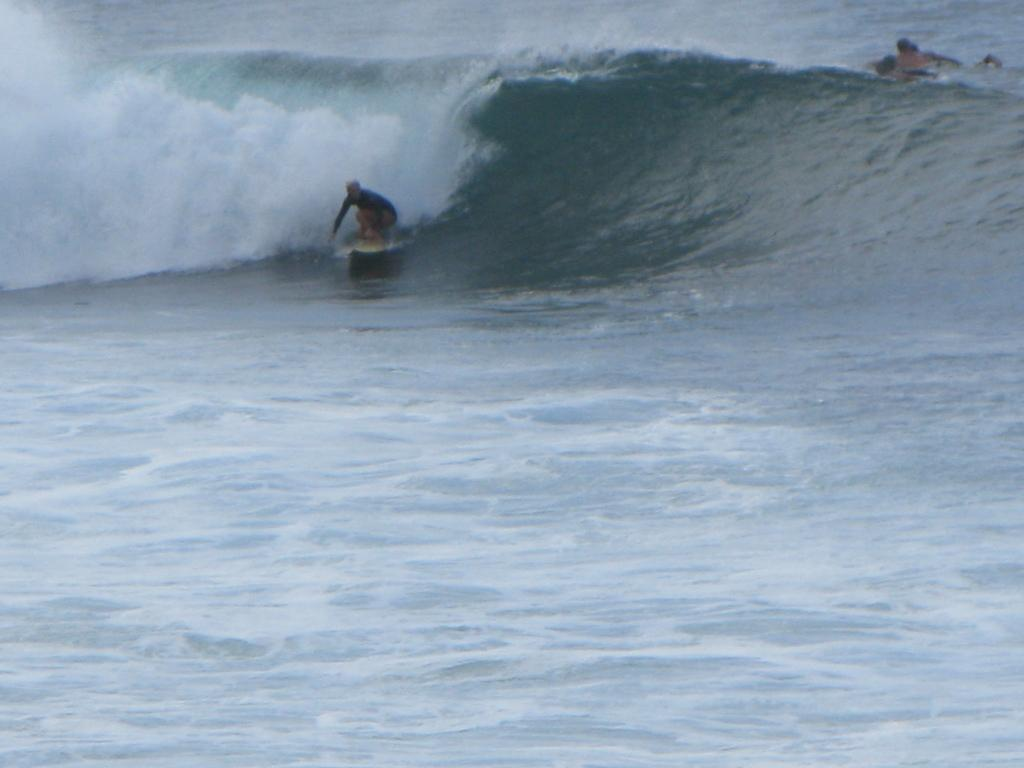What is the main activity taking place in the foreground of the image? There is a man surfing in the foreground of the image. Can you describe the secondary activity in the background of the image? There is a person on the water in the background of the image. How many cherries are floating on the water next to the surfer? There are no cherries visible in the image; it features a man surfing and a person on the water. What is the wish of the person on the water in the image? There is no indication of a wish in the image, as it only shows a person on the water and a man surfing. 